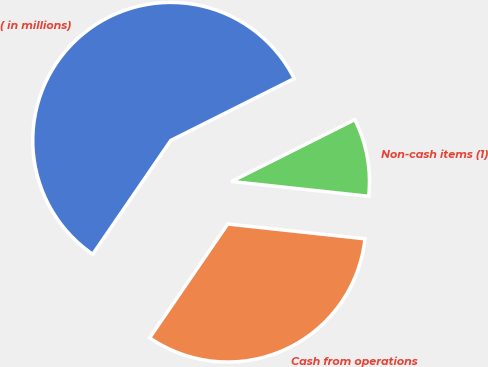Convert chart to OTSL. <chart><loc_0><loc_0><loc_500><loc_500><pie_chart><fcel>( in millions)<fcel>Cash from operations<fcel>Non-cash items (1)<nl><fcel>58.03%<fcel>32.86%<fcel>9.11%<nl></chart> 